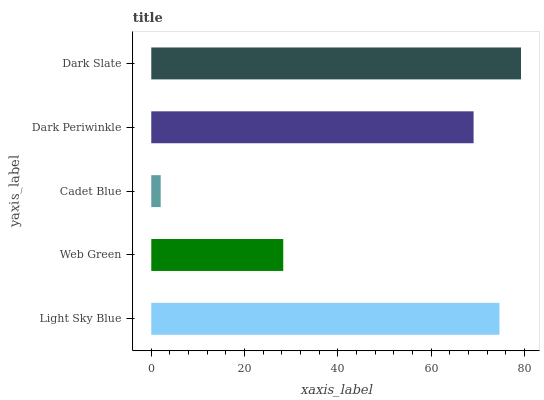Is Cadet Blue the minimum?
Answer yes or no. Yes. Is Dark Slate the maximum?
Answer yes or no. Yes. Is Web Green the minimum?
Answer yes or no. No. Is Web Green the maximum?
Answer yes or no. No. Is Light Sky Blue greater than Web Green?
Answer yes or no. Yes. Is Web Green less than Light Sky Blue?
Answer yes or no. Yes. Is Web Green greater than Light Sky Blue?
Answer yes or no. No. Is Light Sky Blue less than Web Green?
Answer yes or no. No. Is Dark Periwinkle the high median?
Answer yes or no. Yes. Is Dark Periwinkle the low median?
Answer yes or no. Yes. Is Dark Slate the high median?
Answer yes or no. No. Is Light Sky Blue the low median?
Answer yes or no. No. 